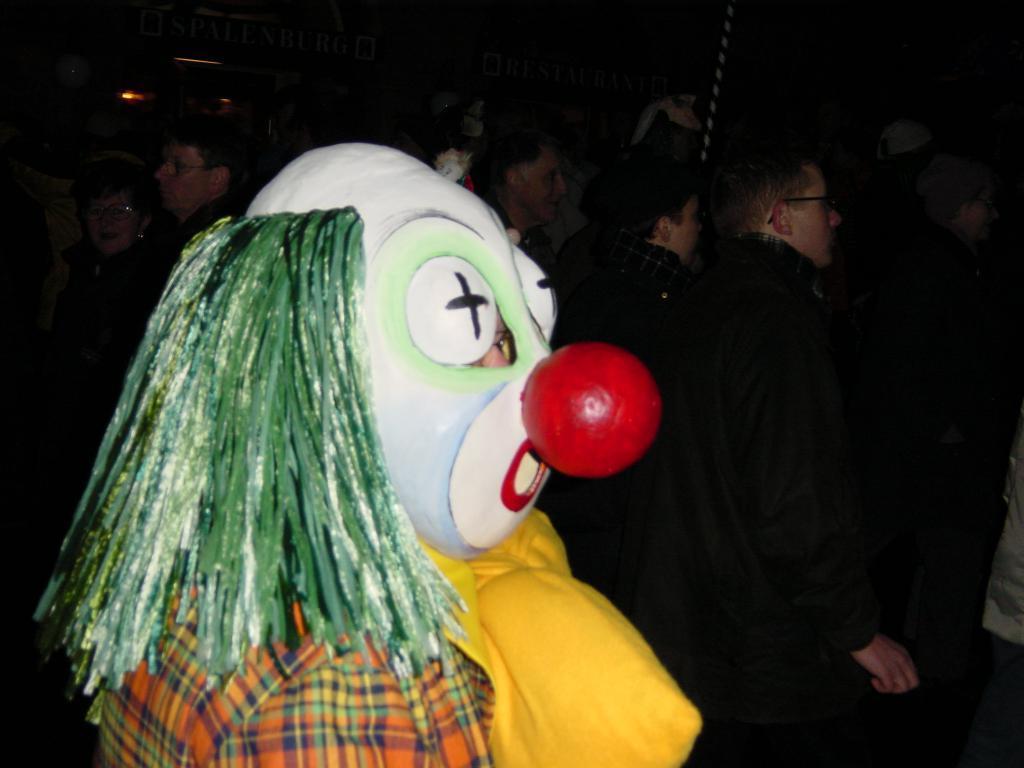Can you describe this image briefly? This picture seems to be clicked inside. In the foreground there is person dressed up like a clown. In the background we can see the group of people and some other objects. 